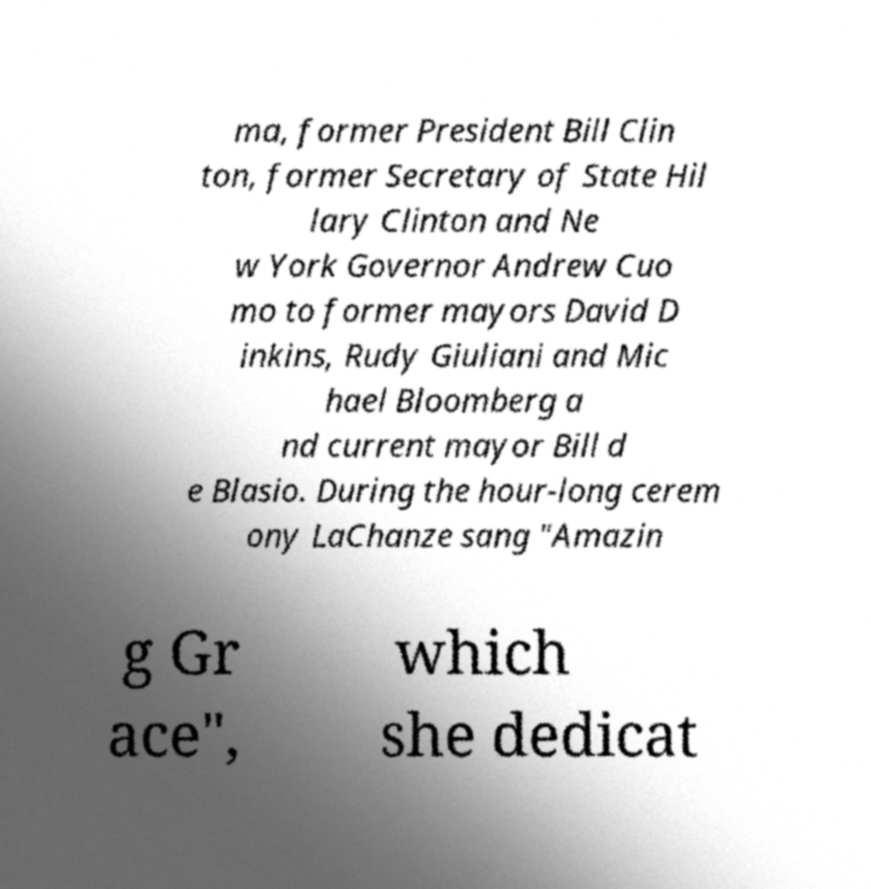Can you read and provide the text displayed in the image?This photo seems to have some interesting text. Can you extract and type it out for me? ma, former President Bill Clin ton, former Secretary of State Hil lary Clinton and Ne w York Governor Andrew Cuo mo to former mayors David D inkins, Rudy Giuliani and Mic hael Bloomberg a nd current mayor Bill d e Blasio. During the hour-long cerem ony LaChanze sang "Amazin g Gr ace", which she dedicat 